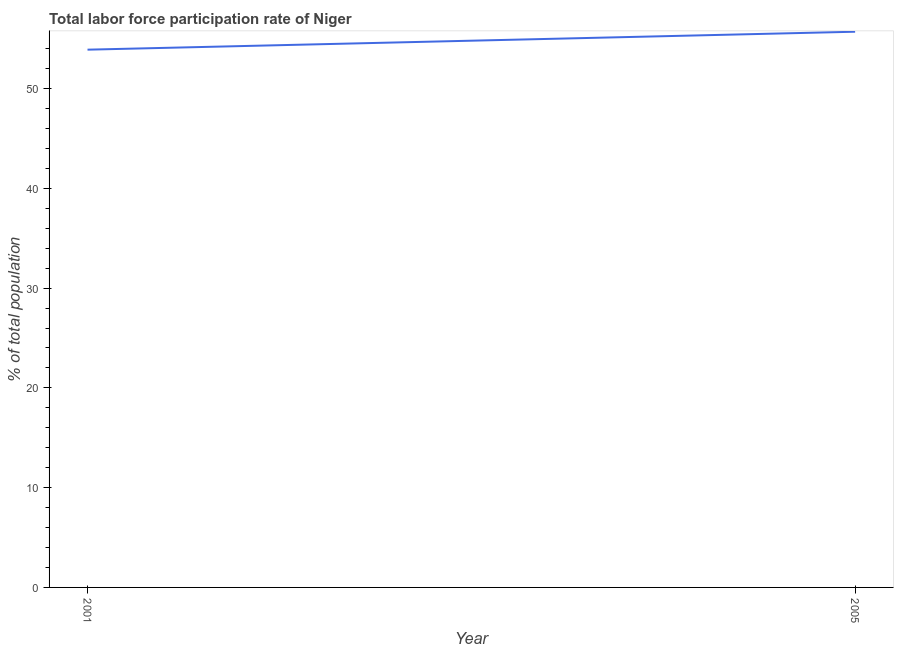What is the total labor force participation rate in 2005?
Your response must be concise. 55.7. Across all years, what is the maximum total labor force participation rate?
Provide a short and direct response. 55.7. Across all years, what is the minimum total labor force participation rate?
Provide a succinct answer. 53.9. In which year was the total labor force participation rate minimum?
Offer a very short reply. 2001. What is the sum of the total labor force participation rate?
Provide a succinct answer. 109.6. What is the difference between the total labor force participation rate in 2001 and 2005?
Keep it short and to the point. -1.8. What is the average total labor force participation rate per year?
Your answer should be very brief. 54.8. What is the median total labor force participation rate?
Your answer should be compact. 54.8. Do a majority of the years between 2001 and 2005 (inclusive) have total labor force participation rate greater than 12 %?
Make the answer very short. Yes. What is the ratio of the total labor force participation rate in 2001 to that in 2005?
Provide a short and direct response. 0.97. Is the total labor force participation rate in 2001 less than that in 2005?
Offer a terse response. Yes. Does the total labor force participation rate monotonically increase over the years?
Your response must be concise. Yes. How many lines are there?
Make the answer very short. 1. Are the values on the major ticks of Y-axis written in scientific E-notation?
Ensure brevity in your answer.  No. Does the graph contain any zero values?
Keep it short and to the point. No. Does the graph contain grids?
Offer a terse response. No. What is the title of the graph?
Provide a succinct answer. Total labor force participation rate of Niger. What is the label or title of the Y-axis?
Offer a terse response. % of total population. What is the % of total population of 2001?
Offer a very short reply. 53.9. What is the % of total population in 2005?
Offer a very short reply. 55.7. What is the difference between the % of total population in 2001 and 2005?
Offer a terse response. -1.8. What is the ratio of the % of total population in 2001 to that in 2005?
Your answer should be compact. 0.97. 